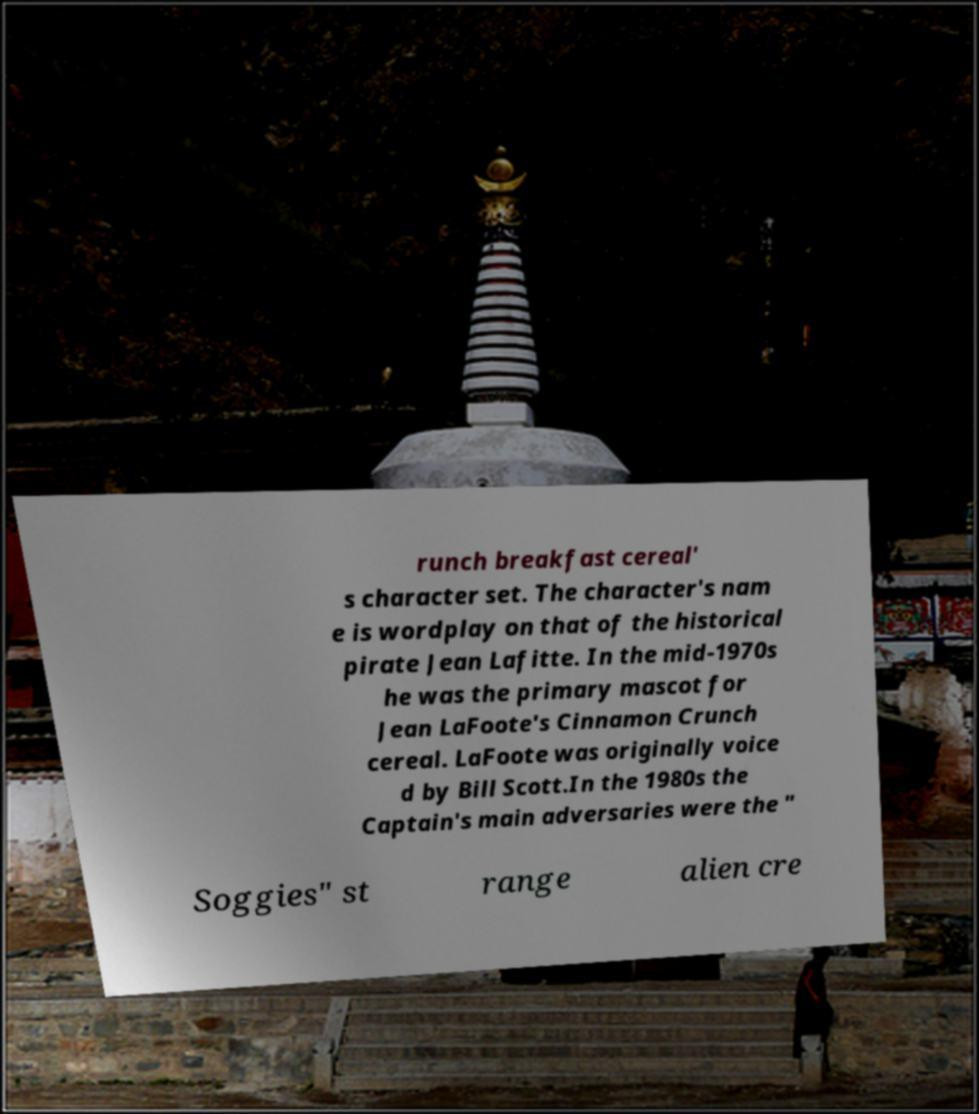Please read and relay the text visible in this image. What does it say? runch breakfast cereal' s character set. The character's nam e is wordplay on that of the historical pirate Jean Lafitte. In the mid-1970s he was the primary mascot for Jean LaFoote's Cinnamon Crunch cereal. LaFoote was originally voice d by Bill Scott.In the 1980s the Captain's main adversaries were the " Soggies" st range alien cre 